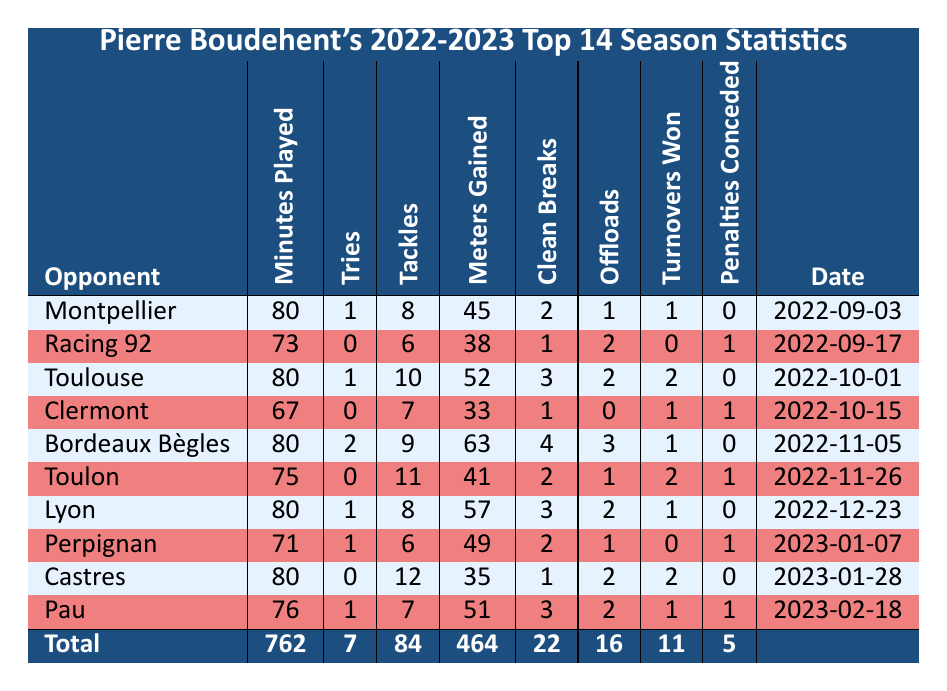What is the total number of tries scored by Pierre Boudehent in the 2022-2023 season? To find the total number of tries, we sum up the tries across all matches. The tries scored are 1, 0, 1, 0, 2, 0, 1, 1, 0, and 1. Adding these gives us 1 + 0 + 1 + 0 + 2 + 0 + 1 + 1 + 0 + 1 = 7.
Answer: 7 How many minutes did Pierre Boudehent play in total during the season? The total minutes played is found by adding the minutes for each game: 80 + 73 + 80 + 67 + 80 + 75 + 80 + 71 + 80 + 76 = 762.
Answer: 762 Did Pierre Boudehent concede any penalties in the match against Montpellier? Looking at the Penalties Conceded column for the match against Montpellier, it shows a value of 0. Thus, he did not concede any penalties in that match.
Answer: No What match did Pierre Boudehent play to achieve the highest meters gained? By examining the Meters Gained column, the highest value is 63, which corresponds to the match against Bordeaux Bègles.
Answer: Bordeaux Bègles What is the average number of tackles made per game? To find the average tackles, we sum the tackles: 8 + 6 + 10 + 7 + 9 + 11 + 8 + 6 + 12 + 7 = 84 tackles across 10 matches. The average is therefore 84 / 10 = 8.4.
Answer: 8.4 How many games did Pierre Boudehent play without scoring a try? He did not score tries in the matches against Racing 92, Clermont, Toulon, and Castres, totaling 4 matches without a try.
Answer: 4 What opponent did he have the most clean breaks against, and how many were there? By reviewing the Clean Breaks column, the most clean breaks recorded is 4, which occurred in the match against Bordeaux Bègles.
Answer: Bordeaux Bègles, 4 Was Pierre Boudehent more effective in offloading in the matches where he scored tries compared to those where he did not? Analyzing the offloads in matches he scored tries (1, 0, 2, 0, 3, 0, 2, 1) gives a total of 9 offloads over 7 matches (average 1.29). Meanwhile, in matches without tries (2, 0, 1, 2) he had 5 offloads across 3 matches (average 1.25). Therefore, he was slightly more effective in offloading in matches with tries.
Answer: Yes, slightly more effective 